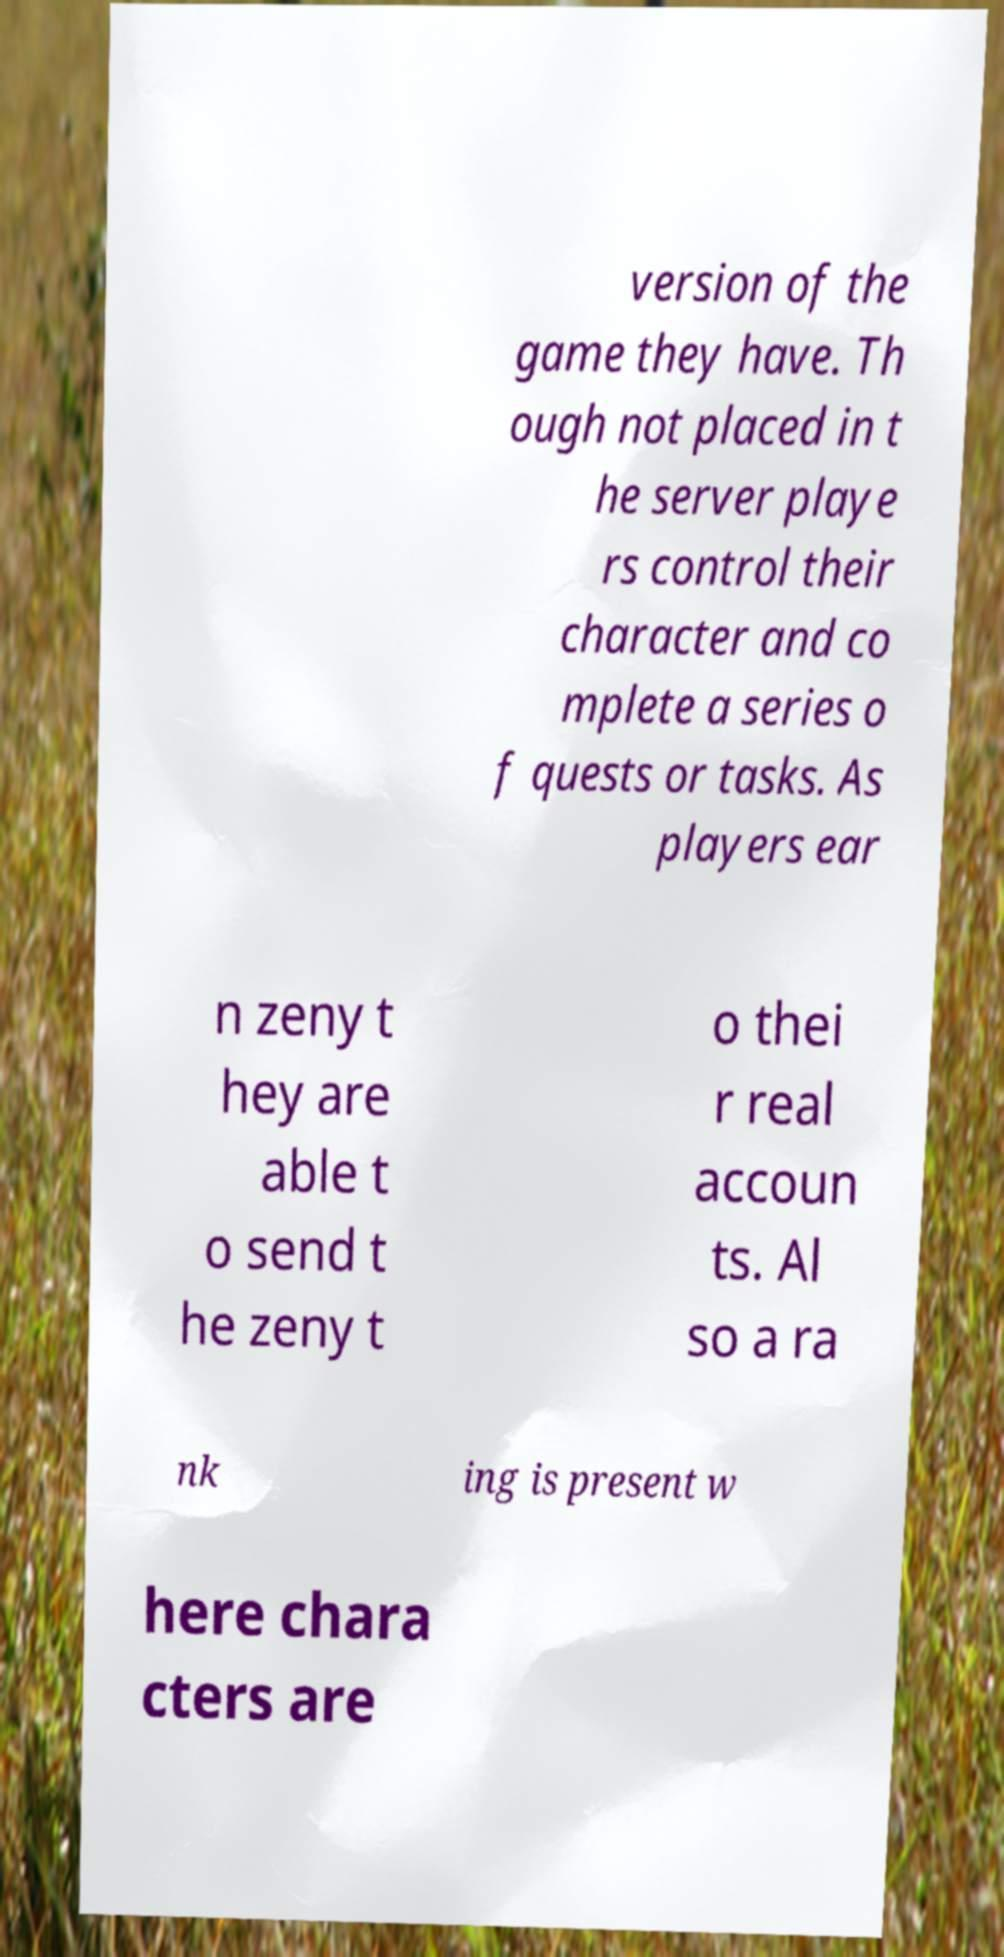Can you read and provide the text displayed in the image?This photo seems to have some interesting text. Can you extract and type it out for me? version of the game they have. Th ough not placed in t he server playe rs control their character and co mplete a series o f quests or tasks. As players ear n zeny t hey are able t o send t he zeny t o thei r real accoun ts. Al so a ra nk ing is present w here chara cters are 